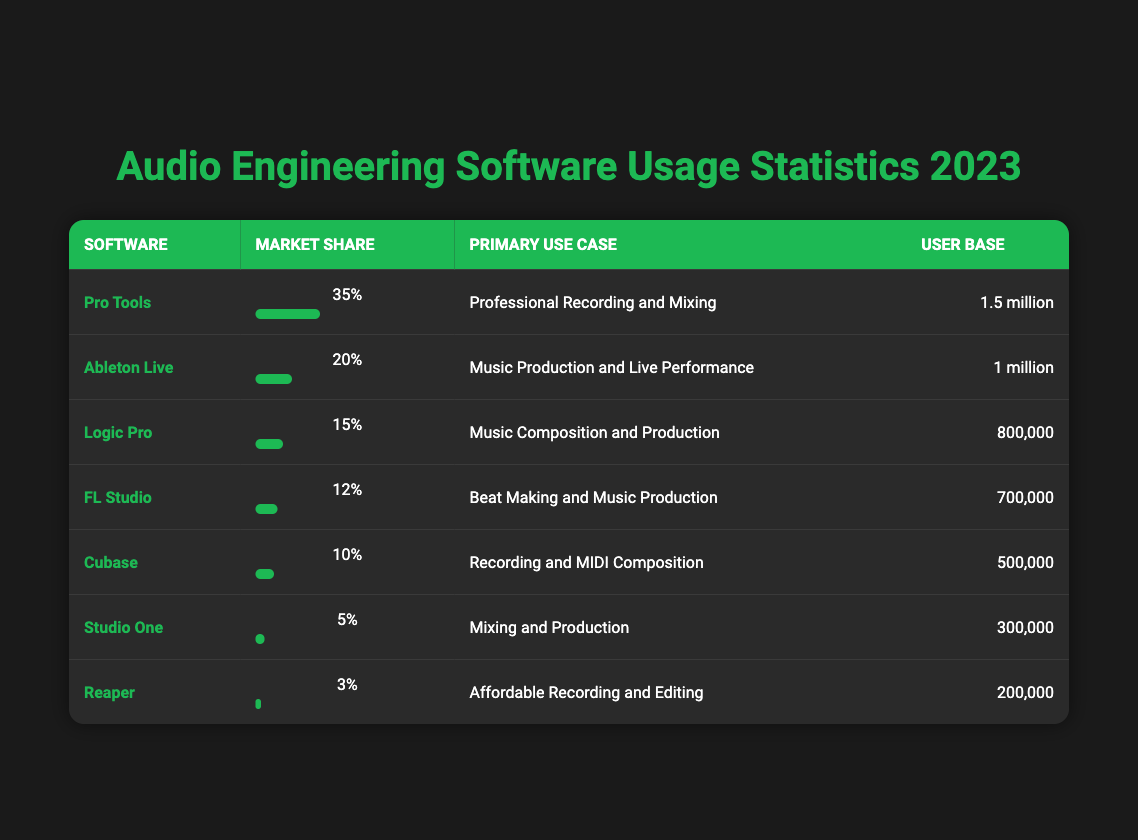What's the software with the highest market share? Looking at the "Market Share" column, "Pro Tools" has the highest percentage at 35%.
Answer: Pro Tools Which software is primarily used for music composition and production? In the "Primary Use Case" column, "Logic Pro" is listed as the software primarily used for music composition and production.
Answer: Logic Pro How many users does FL Studio have? In the "User Base" column for "FL Studio," it shows that FL Studio has a user base of 700,000.
Answer: 700,000 What is the combined market share of Logic Pro and Cubase? The market share for Logic Pro is 15% and for Cubase, it is 10%. Adding these together gives 15% + 10% = 25%.
Answer: 25% Is Studio One more popular than Reaper based on user base? The user base for Studio One is 300,000, while for Reaper it is 200,000. Since 300,000 is greater than 200,000, Studio One is more popular than Reaper in terms of users.
Answer: Yes What percentage of the market share is occupied by software other than Pro Tools and Ableton Live? First, calculate the market share of Pro Tools (35%) and Ableton Live (20%), which totals 55%. The remaining percentage is 100% - 55% = 45%.
Answer: 45% What is the primary use case for software that has a user base of 1 million? Checking the "User Base" column, "Ableton Live" has a user base of 1 million, and its primary use case is music production and live performance.
Answer: Music Production and Live Performance If you combine the user bases of Studio One and Reaper, how many users will you have? The user base for Studio One is 300,000 and for Reaper it is 200,000. Adding these gives 300,000 + 200,000 = 500,000 users combined.
Answer: 500,000 Is it true that Cubase is used more than Studio One? Cubase has a user base of 500,000, while Studio One has 300,000. Since 500,000 is greater than 300,000, Cubase is indeed used more than Studio One.
Answer: Yes 